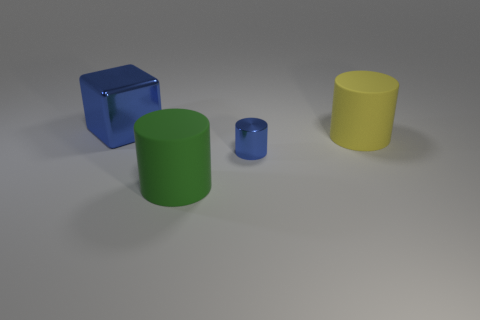Add 3 green cylinders. How many objects exist? 7 Subtract all cylinders. How many objects are left? 1 Add 2 tiny yellow matte blocks. How many tiny yellow matte blocks exist? 2 Subtract 0 blue spheres. How many objects are left? 4 Subtract all big green objects. Subtract all large yellow matte cylinders. How many objects are left? 2 Add 4 big blue shiny blocks. How many big blue shiny blocks are left? 5 